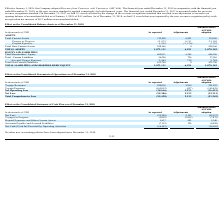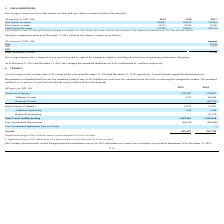From Nordic American Tankers Limited's financial document, What are the respective spot charter revenues in 2018 and 2019? The document shows two values: 259,978 and 283,007 (in thousands). From the document: "Spot charter revenues * 283,007 259,978 257,495 Spot charter revenues * 283,007 259,978 257,495..." Also, What are the respective time charter revenues in 2018 and 2019? The document shows two values: 29,038 and 34,213 (in thousands). From the document: "Time charter revenues 34,213 29,038 39,646 Time charter revenues 34,213 29,038 39,646..." Also, What are the respective total voyage revenues in 2018 and 2019? The document shows two values: 289,016 and 317,220 (in thousands). From the document: "Total Voyage Revenues 317,220 289,016 297,141 Total Voyage Revenues 317,220 289,016 297,141..." Also, can you calculate: What is the value of the 2019 spot charter revenues as a percentage of the 2018 spot charter revenues? Based on the calculation: 283,007/259,978 , the result is 108.86 (percentage). This is based on the information: "Spot charter revenues * 283,007 259,978 257,495 Spot charter revenues * 283,007 259,978 257,495..." The key data points involved are: 259,978, 283,007. Also, can you calculate: What is the value of the 2019 time charter revenues as a percentage of the 2018 time charter revenues? Based on the calculation: 34,213/29,038 , the result is 117.82 (percentage). This is based on the information: "Time charter revenues 34,213 29,038 39,646 Time charter revenues 34,213 29,038 39,646..." The key data points involved are: 29,038, 34,213. Also, can you calculate: What is the value of the 2019 total voyage revenue as a percentage of the 2018 total voyage revenues? Based on the calculation: 317,220/289,016 , the result is 109.76 (percentage). This is based on the information: "Total Voyage Revenues 317,220 289,016 297,141 Total Voyage Revenues 317,220 289,016 297,141..." The key data points involved are: 289,016, 317,220. 